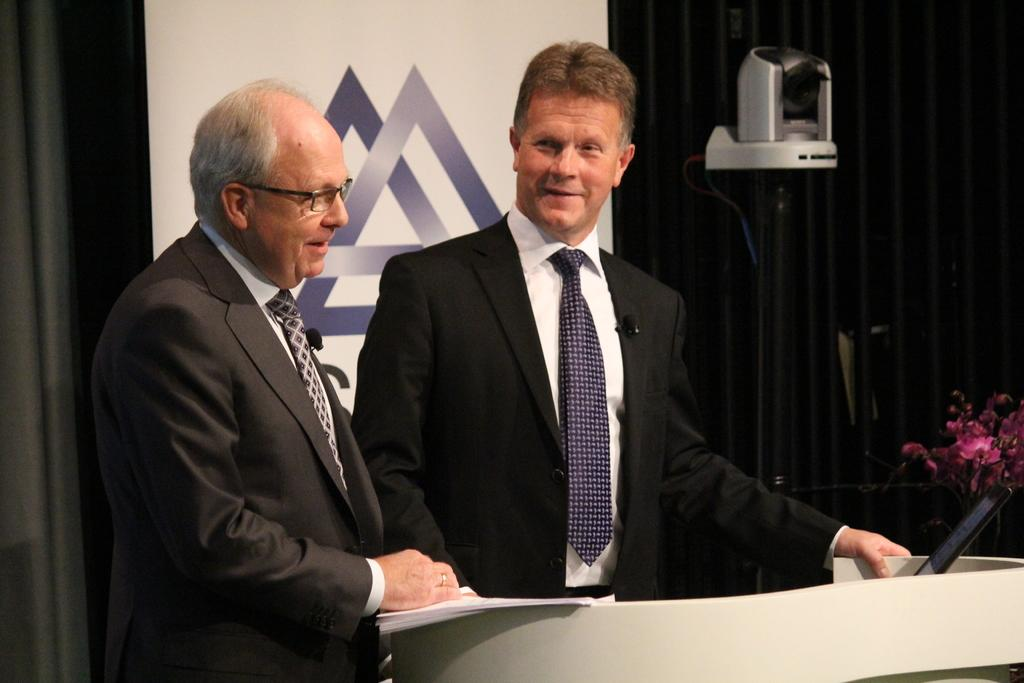How many men are in the image? There are two men in the image. What are the men doing in the image? The men are standing and smiling. What are the men wearing in the image? The men are wearing blazers and ties. What can be seen in the background of the image? There is a banner and a curtain in the background of the image. How does the salt contribute to the comfort of the men in the image? There is no salt present in the image, so it cannot contribute to the comfort of the men. 